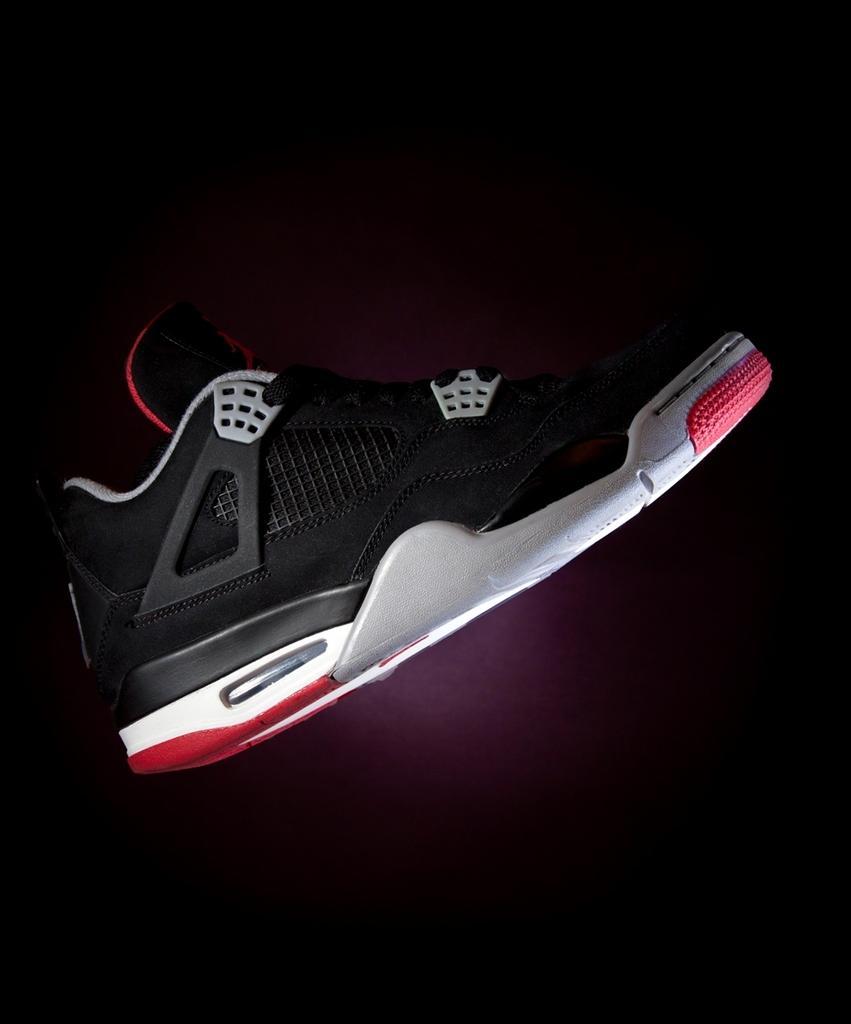In one or two sentences, can you explain what this image depicts? In this image we can see a shoe. 